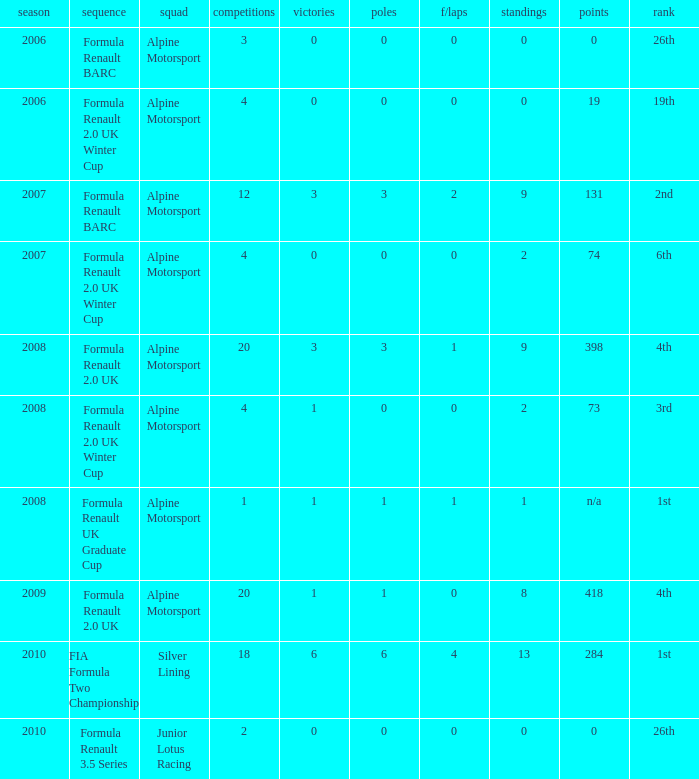What races achieved 0 f/laps and 1 pole position? 20.0. 